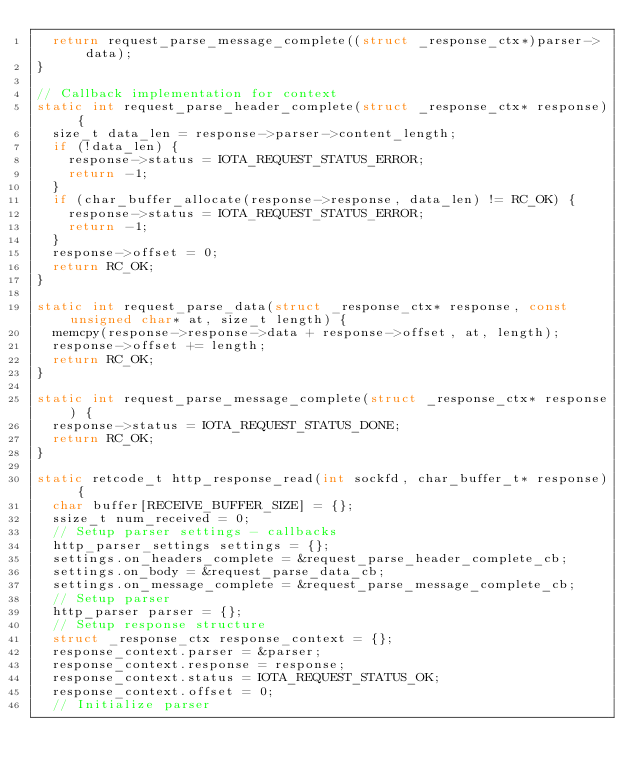Convert code to text. <code><loc_0><loc_0><loc_500><loc_500><_C_>  return request_parse_message_complete((struct _response_ctx*)parser->data);
}

// Callback implementation for context
static int request_parse_header_complete(struct _response_ctx* response) {
  size_t data_len = response->parser->content_length;
  if (!data_len) {
    response->status = IOTA_REQUEST_STATUS_ERROR;
    return -1;
  }
  if (char_buffer_allocate(response->response, data_len) != RC_OK) {
    response->status = IOTA_REQUEST_STATUS_ERROR;
    return -1;
  }
  response->offset = 0;
  return RC_OK;
}

static int request_parse_data(struct _response_ctx* response, const unsigned char* at, size_t length) {
  memcpy(response->response->data + response->offset, at, length);
  response->offset += length;
  return RC_OK;
}

static int request_parse_message_complete(struct _response_ctx* response) {
  response->status = IOTA_REQUEST_STATUS_DONE;
  return RC_OK;
}

static retcode_t http_response_read(int sockfd, char_buffer_t* response) {
  char buffer[RECEIVE_BUFFER_SIZE] = {};
  ssize_t num_received = 0;
  // Setup parser settings - callbacks
  http_parser_settings settings = {};
  settings.on_headers_complete = &request_parse_header_complete_cb;
  settings.on_body = &request_parse_data_cb;
  settings.on_message_complete = &request_parse_message_complete_cb;
  // Setup parser
  http_parser parser = {};
  // Setup response structure
  struct _response_ctx response_context = {};
  response_context.parser = &parser;
  response_context.response = response;
  response_context.status = IOTA_REQUEST_STATUS_OK;
  response_context.offset = 0;
  // Initialize parser</code> 